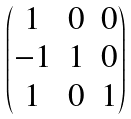Convert formula to latex. <formula><loc_0><loc_0><loc_500><loc_500>\begin{pmatrix} 1 & 0 & 0 \\ - 1 & 1 & 0 \\ 1 & 0 & 1 \end{pmatrix}</formula> 